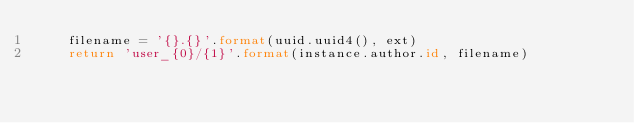<code> <loc_0><loc_0><loc_500><loc_500><_Python_>    filename = '{}.{}'.format(uuid.uuid4(), ext)
    return 'user_{0}/{1}'.format(instance.author.id, filename)
</code> 